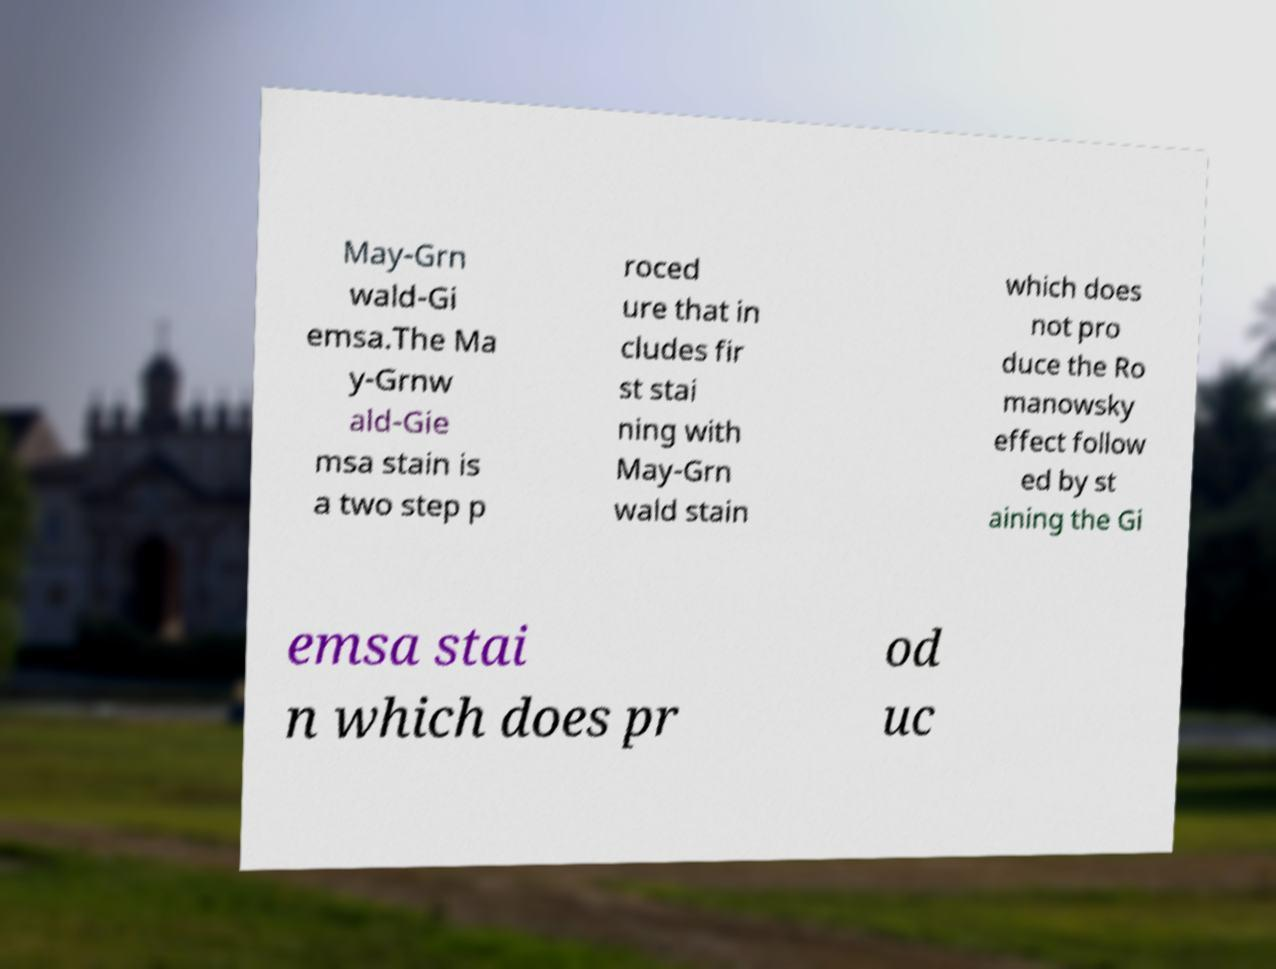For documentation purposes, I need the text within this image transcribed. Could you provide that? May-Grn wald-Gi emsa.The Ma y-Grnw ald-Gie msa stain is a two step p roced ure that in cludes fir st stai ning with May-Grn wald stain which does not pro duce the Ro manowsky effect follow ed by st aining the Gi emsa stai n which does pr od uc 